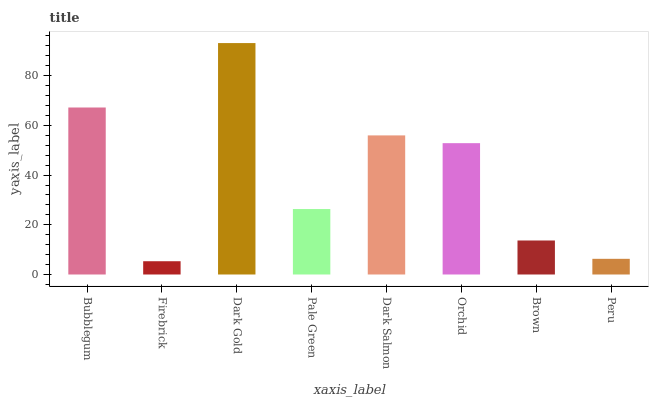Is Firebrick the minimum?
Answer yes or no. Yes. Is Dark Gold the maximum?
Answer yes or no. Yes. Is Dark Gold the minimum?
Answer yes or no. No. Is Firebrick the maximum?
Answer yes or no. No. Is Dark Gold greater than Firebrick?
Answer yes or no. Yes. Is Firebrick less than Dark Gold?
Answer yes or no. Yes. Is Firebrick greater than Dark Gold?
Answer yes or no. No. Is Dark Gold less than Firebrick?
Answer yes or no. No. Is Orchid the high median?
Answer yes or no. Yes. Is Pale Green the low median?
Answer yes or no. Yes. Is Peru the high median?
Answer yes or no. No. Is Peru the low median?
Answer yes or no. No. 